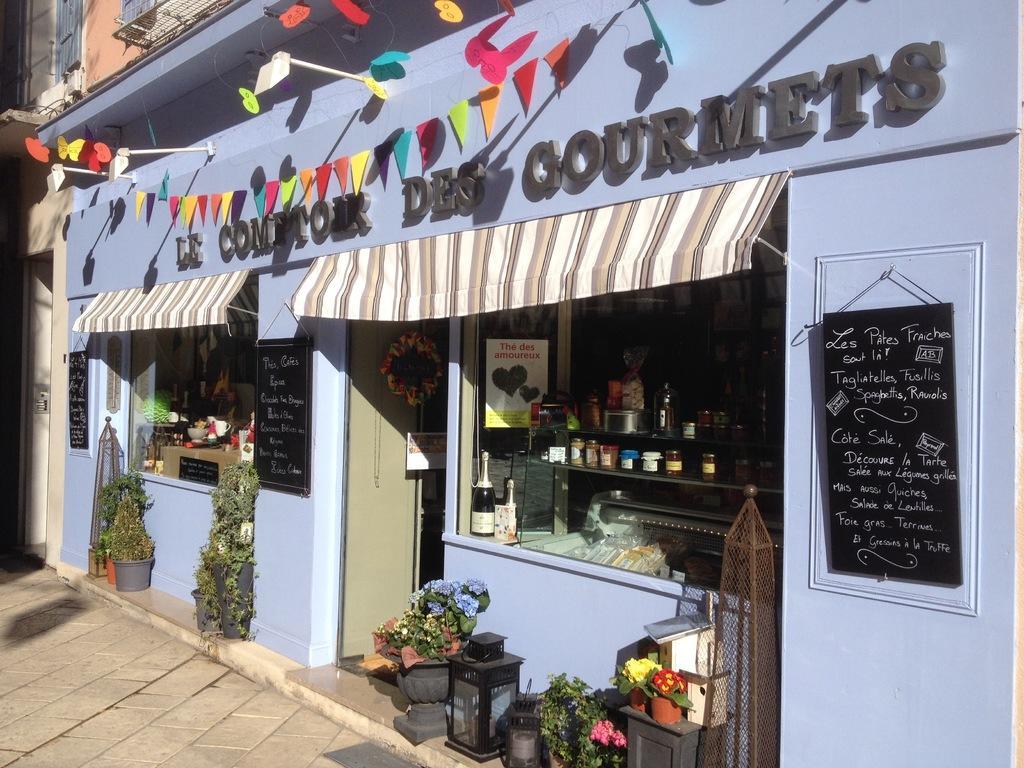Could you give a brief overview of what you see in this image? In this image we can see a building, there is a wine bottle, there are bottles and some objects on it, there is a door, there is a black board and something written on it, there are flower pots, there is a name board, there are lights, there are flags. 